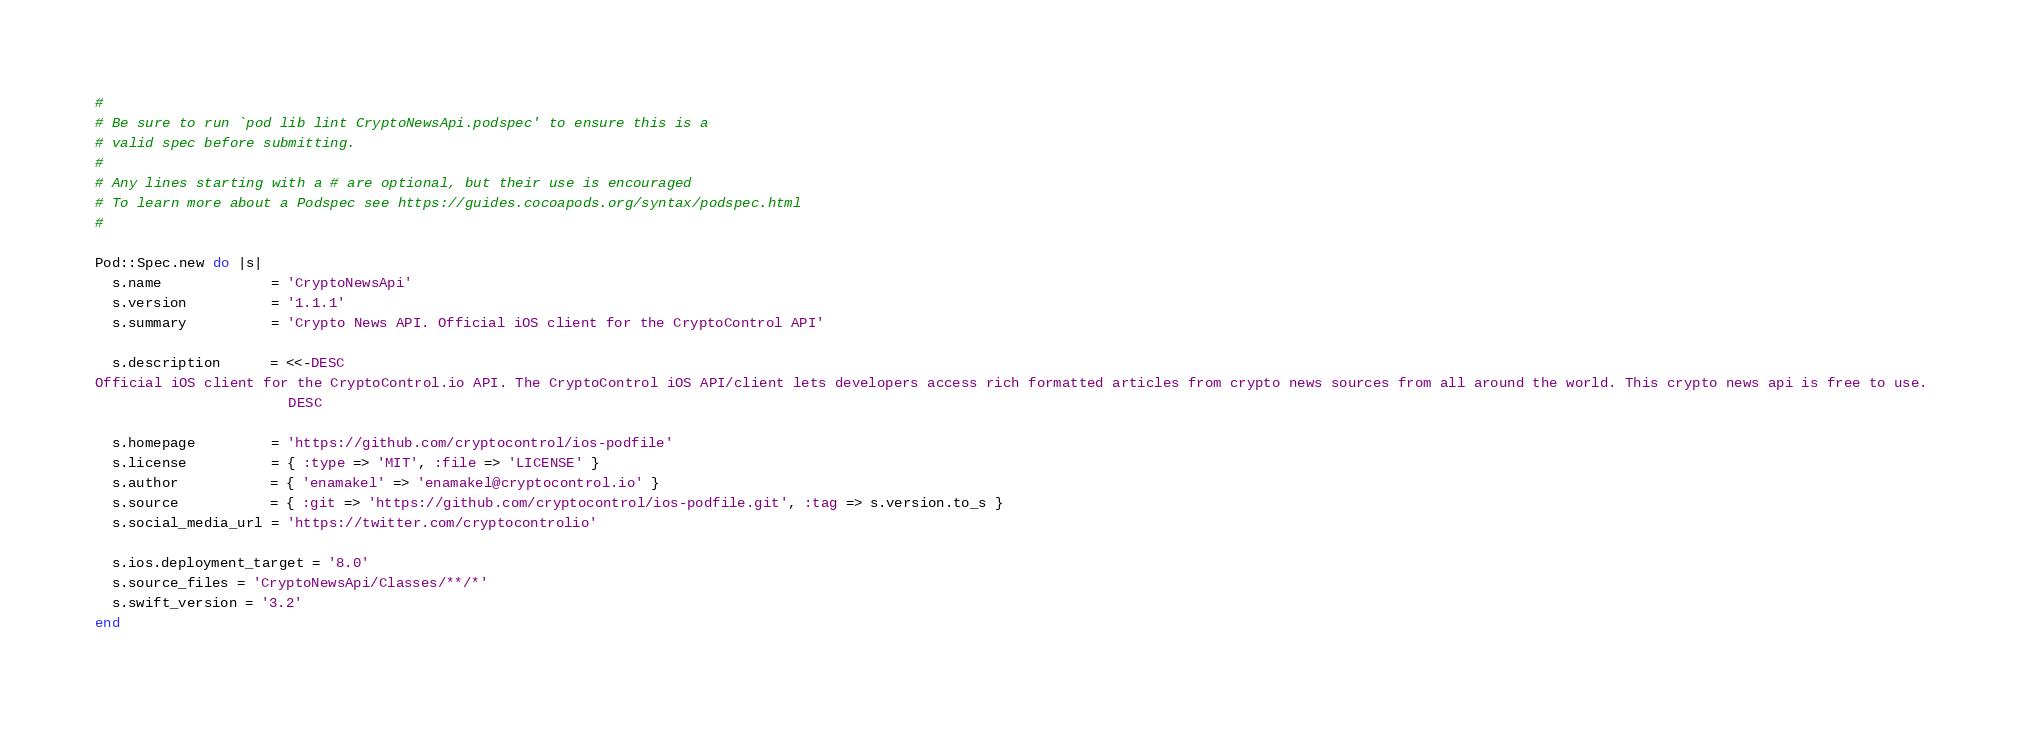Convert code to text. <code><loc_0><loc_0><loc_500><loc_500><_Ruby_>#
# Be sure to run `pod lib lint CryptoNewsApi.podspec' to ensure this is a
# valid spec before submitting.
#
# Any lines starting with a # are optional, but their use is encouraged
# To learn more about a Podspec see https://guides.cocoapods.org/syntax/podspec.html
#

Pod::Spec.new do |s|
  s.name             = 'CryptoNewsApi'
  s.version          = '1.1.1'
  s.summary          = 'Crypto News API. Official iOS client for the CryptoControl API'

  s.description      = <<-DESC
Official iOS client for the CryptoControl.io API. The CryptoControl iOS API/client lets developers access rich formatted articles from crypto news sources from all around the world. This crypto news api is free to use.
                       DESC

  s.homepage         = 'https://github.com/cryptocontrol/ios-podfile'
  s.license          = { :type => 'MIT', :file => 'LICENSE' }
  s.author           = { 'enamakel' => 'enamakel@cryptocontrol.io' }
  s.source           = { :git => 'https://github.com/cryptocontrol/ios-podfile.git', :tag => s.version.to_s }
  s.social_media_url = 'https://twitter.com/cryptocontrolio'

  s.ios.deployment_target = '8.0'
  s.source_files = 'CryptoNewsApi/Classes/**/*'
  s.swift_version = '3.2'
end
</code> 